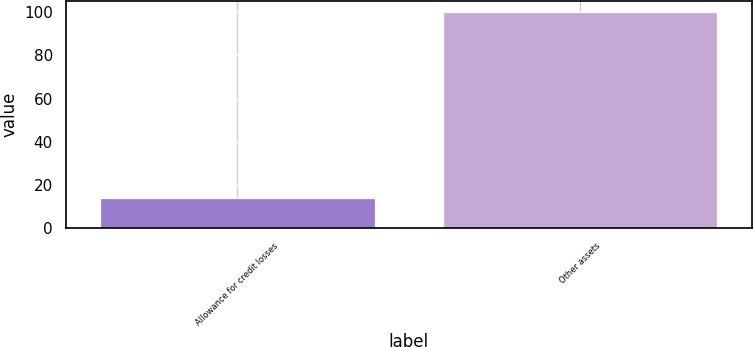Convert chart to OTSL. <chart><loc_0><loc_0><loc_500><loc_500><bar_chart><fcel>Allowance for credit losses<fcel>Other assets<nl><fcel>14<fcel>100<nl></chart> 